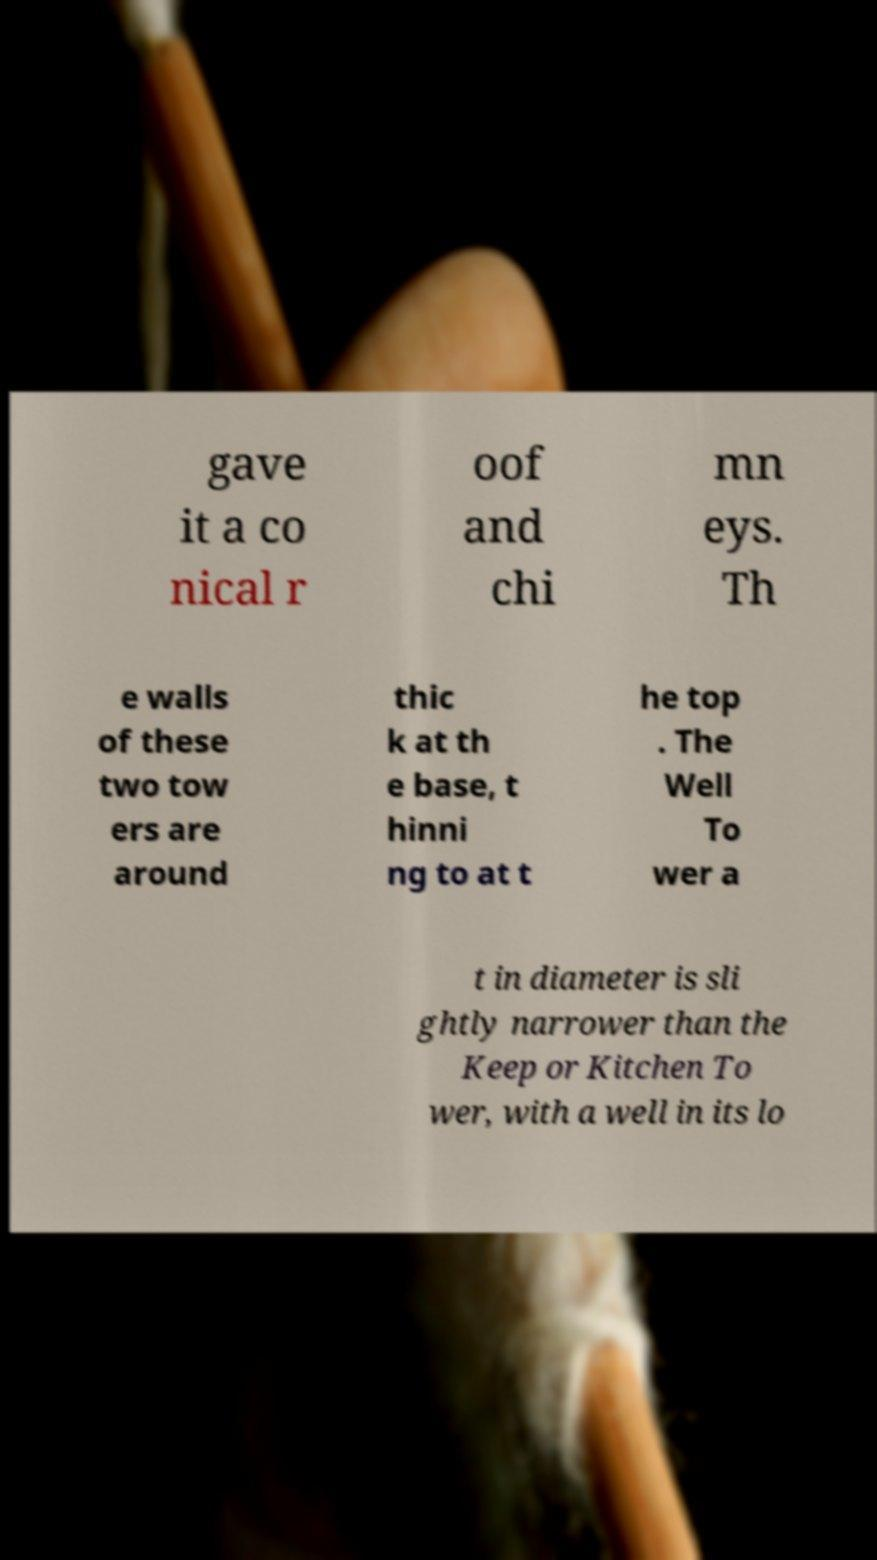Please read and relay the text visible in this image. What does it say? gave it a co nical r oof and chi mn eys. Th e walls of these two tow ers are around thic k at th e base, t hinni ng to at t he top . The Well To wer a t in diameter is sli ghtly narrower than the Keep or Kitchen To wer, with a well in its lo 